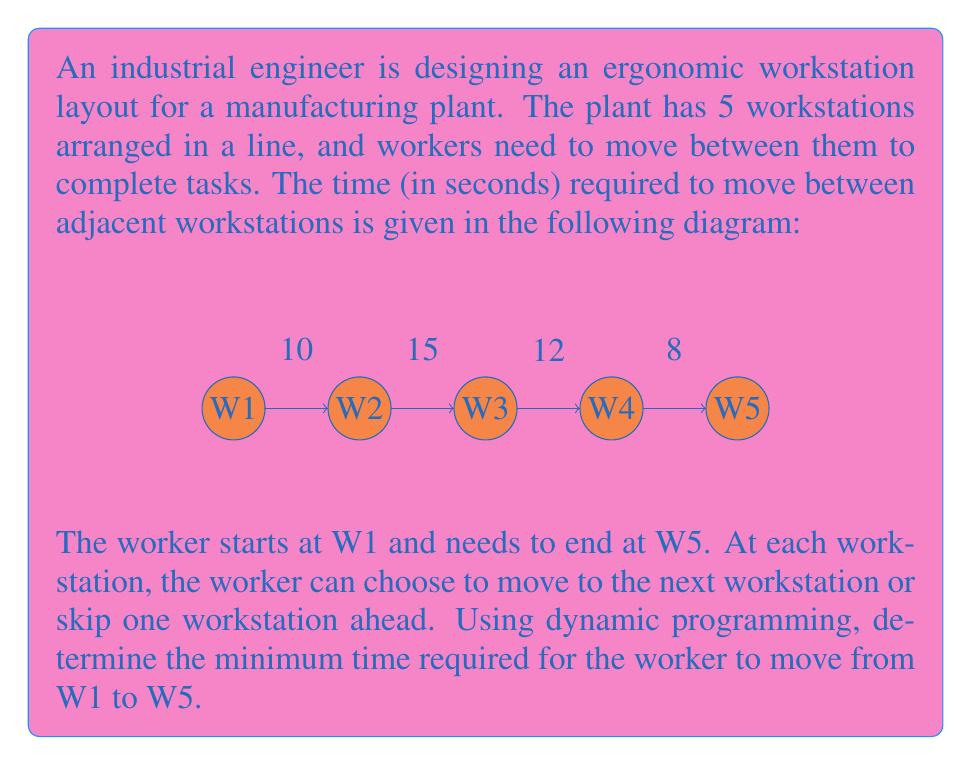Help me with this question. Let's solve this problem using dynamic programming:

1) Define the subproblem:
   Let $f(i)$ be the minimum time required to reach workstation $i$ from W1.

2) Establish the base case:
   $f(1) = 0$ (starting point)

3) Develop the recurrence relation:
   For $i > 1$, we have two options:
   a) Move from the previous workstation: $f(i-1) + \text{time}(i-1, i)$
   b) Skip one workstation: $f(i-2) + \text{time}(i-2, i)$ (if $i > 2$)
   
   Therefore, $f(i) = \min(f(i-1) + \text{time}(i-1, i), f(i-2) + \text{time}(i-2, i))$

4) Solve the subproblems in order:

   $f(1) = 0$
   
   $f(2) = f(1) + \text{time}(1,2) = 0 + 10 = 10$
   
   $f(3) = \min(f(2) + \text{time}(2,3), f(1) + \text{time}(1,3))$
         $= \min(10 + 15, 0 + (10 + 15)) = 25$
   
   $f(4) = \min(f(3) + \text{time}(3,4), f(2) + \text{time}(2,4))$
         $= \min(25 + 12, 10 + (15 + 12)) = \min(37, 37) = 37$
   
   $f(5) = \min(f(4) + \text{time}(4,5), f(3) + \text{time}(3,5))$
         $= \min(37 + 8, 25 + (12 + 8)) = \min(45, 45) = 45$

5) The minimum time to reach W5 from W1 is $f(5) = 45$ seconds.
Answer: 45 seconds 